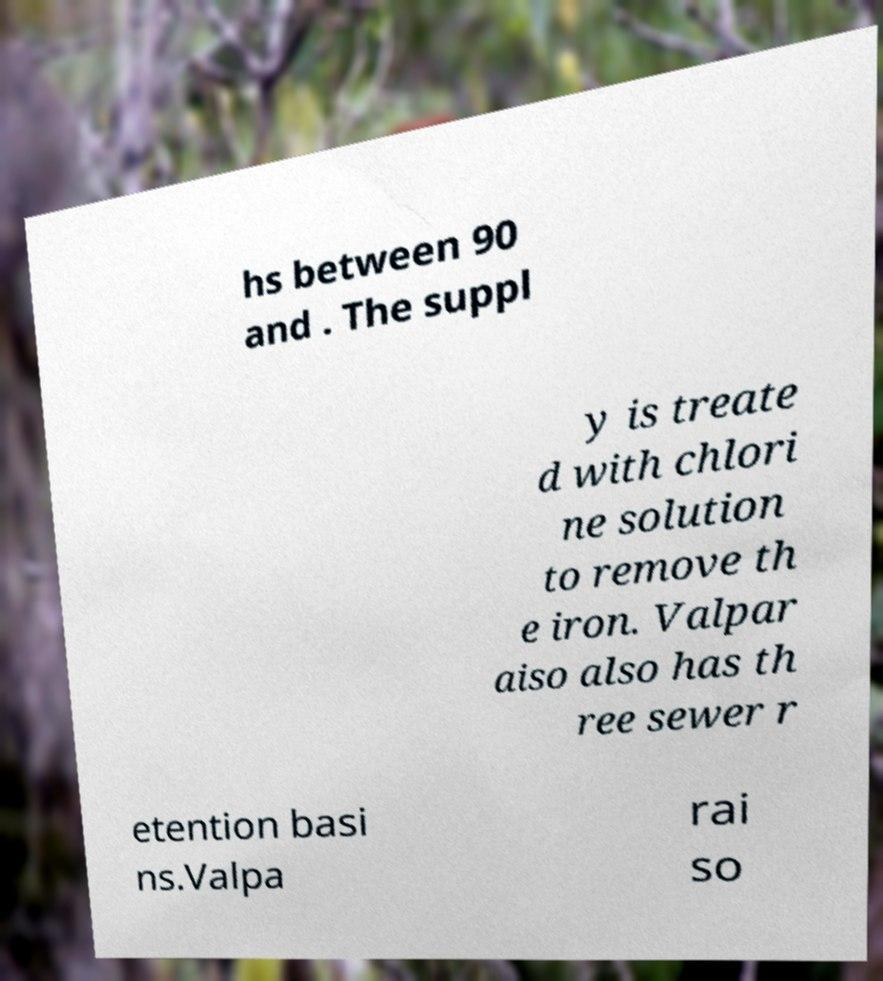Could you extract and type out the text from this image? hs between 90 and . The suppl y is treate d with chlori ne solution to remove th e iron. Valpar aiso also has th ree sewer r etention basi ns.Valpa rai so 